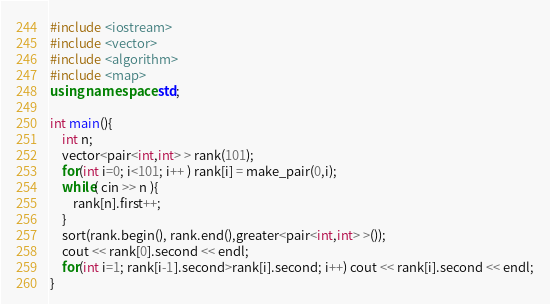Convert code to text. <code><loc_0><loc_0><loc_500><loc_500><_C++_>#include <iostream>
#include <vector>
#include <algorithm>
#include <map>
using namespace std;

int main(){
	int n;
	vector<pair<int,int> > rank(101);
	for(int i=0; i<101; i++ ) rank[i] = make_pair(0,i);
	while( cin >> n ){
		rank[n].first++;
	}
	sort(rank.begin(), rank.end(),greater<pair<int,int> >());
	cout << rank[0].second << endl;
	for(int i=1; rank[i-1].second>rank[i].second; i++) cout << rank[i].second << endl;
}</code> 